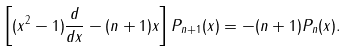<formula> <loc_0><loc_0><loc_500><loc_500>\left [ ( x ^ { 2 } - 1 ) \frac { d } { d x } - ( n + 1 ) x \right ] P _ { n + 1 } ( x ) = - ( n + 1 ) P _ { n } ( x ) .</formula> 